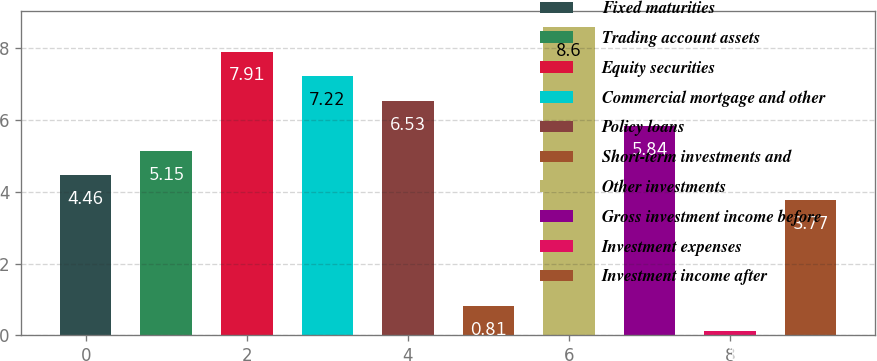Convert chart to OTSL. <chart><loc_0><loc_0><loc_500><loc_500><bar_chart><fcel>Fixed maturities<fcel>Trading account assets<fcel>Equity securities<fcel>Commercial mortgage and other<fcel>Policy loans<fcel>Short-term investments and<fcel>Other investments<fcel>Gross investment income before<fcel>Investment expenses<fcel>Investment income after<nl><fcel>4.46<fcel>5.15<fcel>7.91<fcel>7.22<fcel>6.53<fcel>0.81<fcel>8.6<fcel>5.84<fcel>0.12<fcel>3.77<nl></chart> 